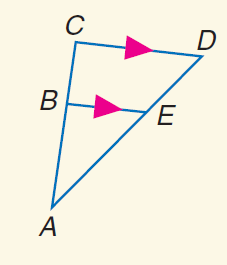Answer the mathemtical geometry problem and directly provide the correct option letter.
Question: Find B C if B E = 24, C D = 32, and A B = 33.
Choices: A: 11 B: 12 C: 16 D: 44 A 